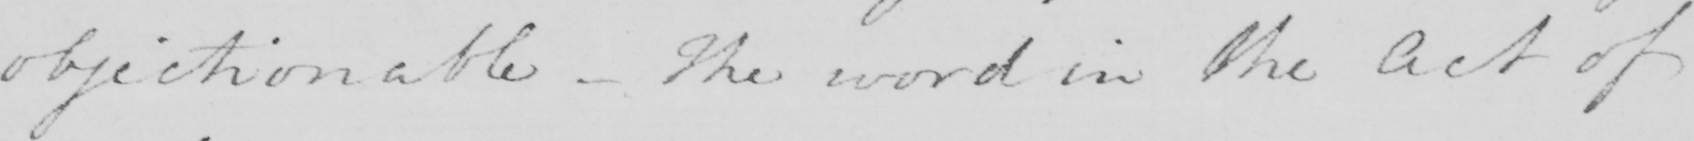Transcribe the text shown in this historical manuscript line. objectionable  _  The word in the Act of 